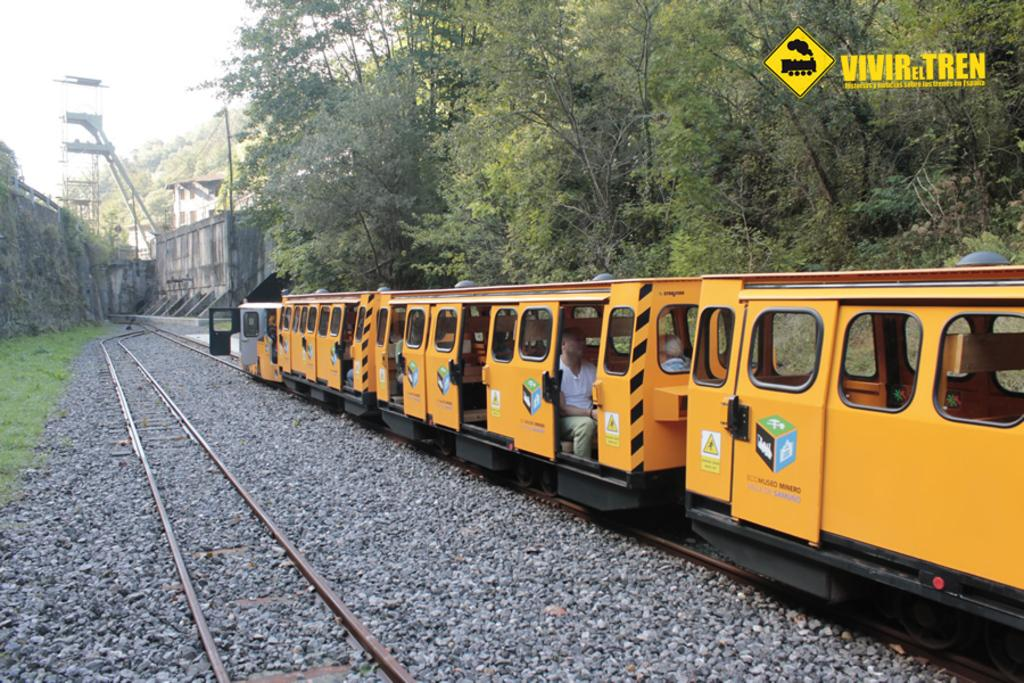What is the main subject of the image? The main subject of the image is a train. What is the train doing in the image? The train is moving on a track in the image. What is the color of the train? The train is yellow in color. What can be seen in the background of the image? There are trees visible behind the train in the image. What type of arm is visible on the train in the image? There are no arms visible on the train in the image; it is a vehicle with no human-like features. 